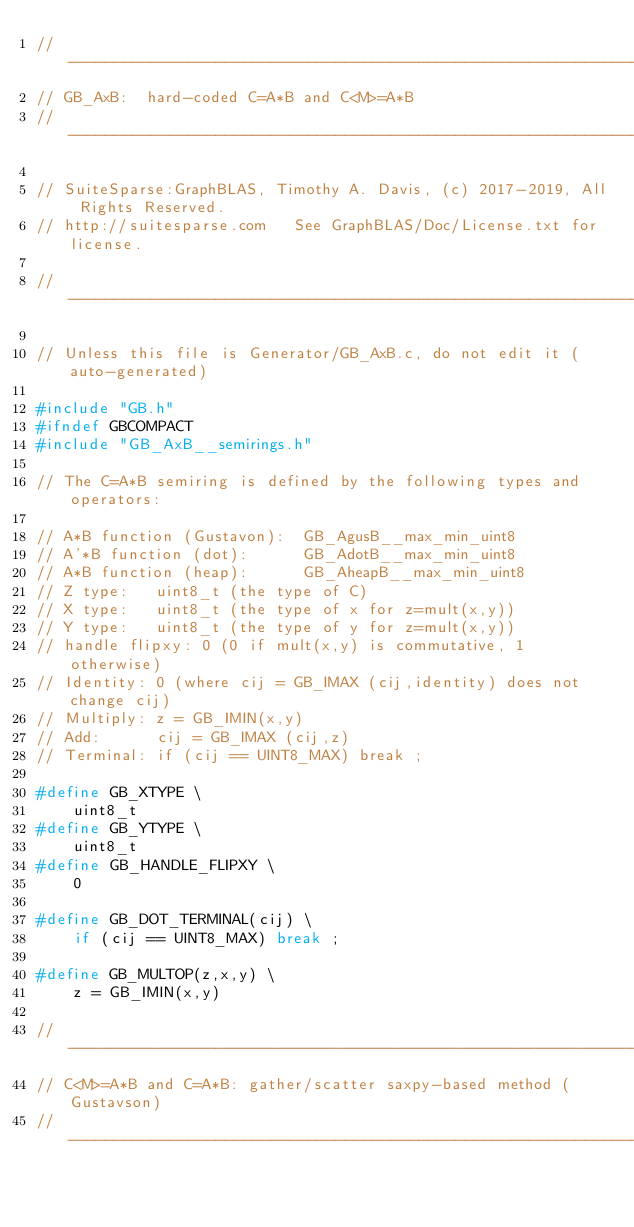Convert code to text. <code><loc_0><loc_0><loc_500><loc_500><_C_>//------------------------------------------------------------------------------
// GB_AxB:  hard-coded C=A*B and C<M>=A*B
//------------------------------------------------------------------------------

// SuiteSparse:GraphBLAS, Timothy A. Davis, (c) 2017-2019, All Rights Reserved.
// http://suitesparse.com   See GraphBLAS/Doc/License.txt for license.

//------------------------------------------------------------------------------

// Unless this file is Generator/GB_AxB.c, do not edit it (auto-generated)

#include "GB.h"
#ifndef GBCOMPACT
#include "GB_AxB__semirings.h"

// The C=A*B semiring is defined by the following types and operators:

// A*B function (Gustavon):  GB_AgusB__max_min_uint8
// A'*B function (dot):      GB_AdotB__max_min_uint8
// A*B function (heap):      GB_AheapB__max_min_uint8
// Z type:   uint8_t (the type of C)
// X type:   uint8_t (the type of x for z=mult(x,y))
// Y type:   uint8_t (the type of y for z=mult(x,y))
// handle flipxy: 0 (0 if mult(x,y) is commutative, 1 otherwise)
// Identity: 0 (where cij = GB_IMAX (cij,identity) does not change cij)
// Multiply: z = GB_IMIN(x,y)
// Add:      cij = GB_IMAX (cij,z)
// Terminal: if (cij == UINT8_MAX) break ;

#define GB_XTYPE \
    uint8_t
#define GB_YTYPE \
    uint8_t
#define GB_HANDLE_FLIPXY \
    0

#define GB_DOT_TERMINAL(cij) \
    if (cij == UINT8_MAX) break ;

#define GB_MULTOP(z,x,y) \
    z = GB_IMIN(x,y)

//------------------------------------------------------------------------------
// C<M>=A*B and C=A*B: gather/scatter saxpy-based method (Gustavson)
//------------------------------------------------------------------------------
</code> 